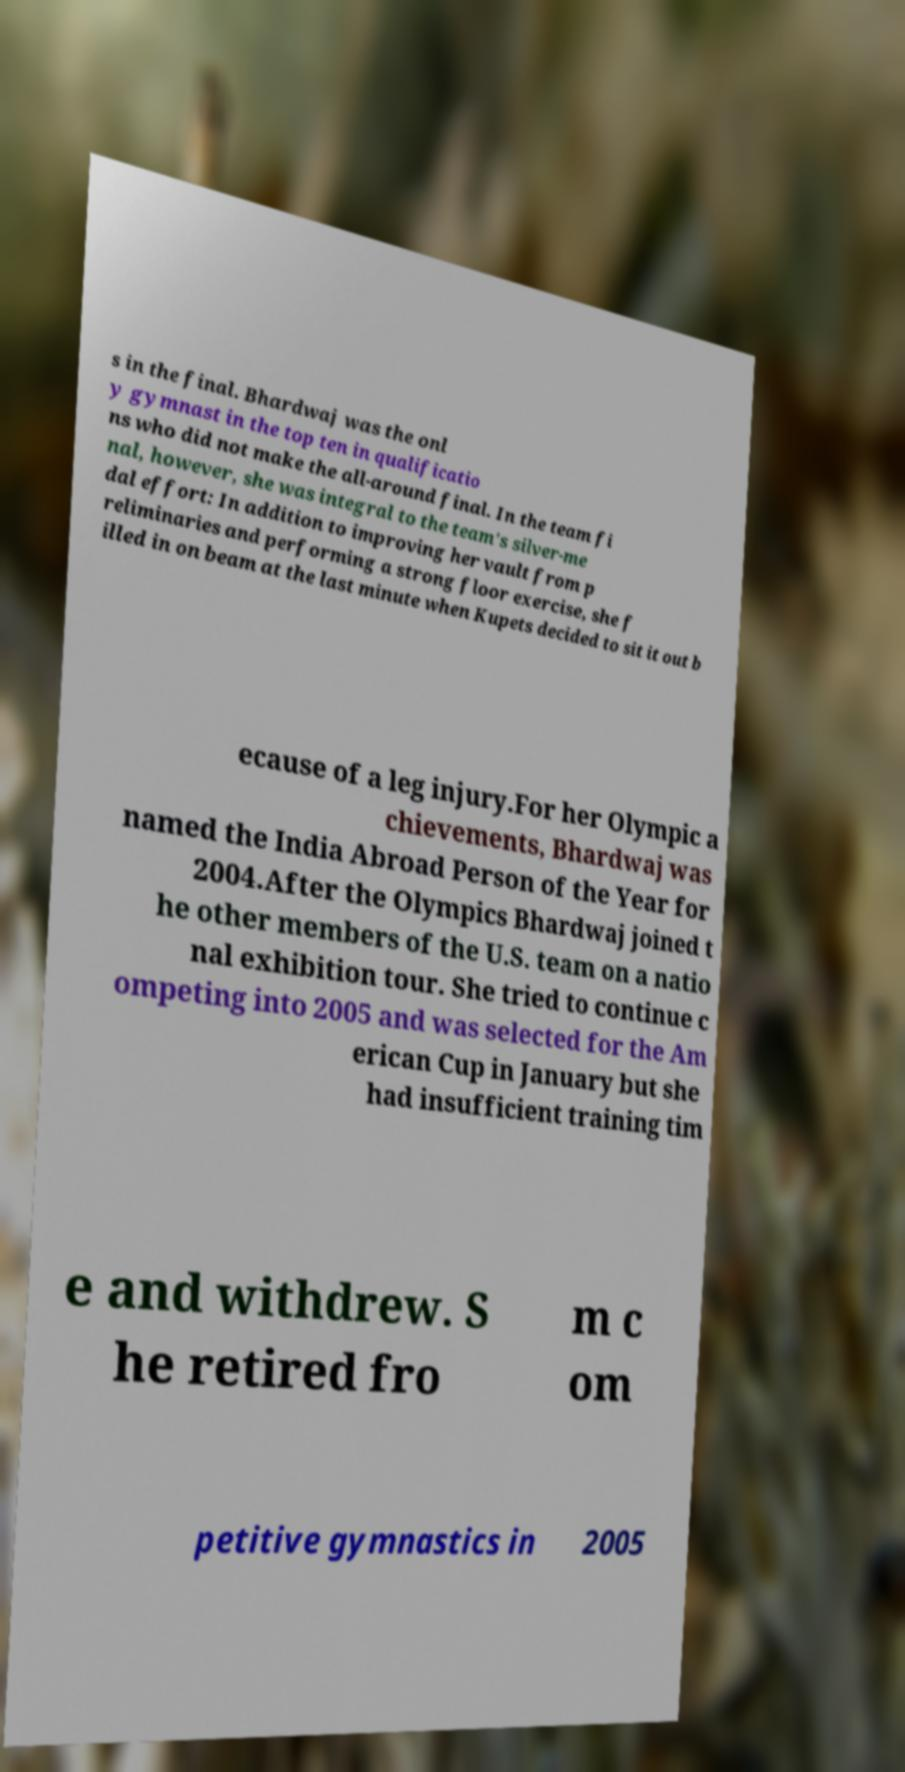There's text embedded in this image that I need extracted. Can you transcribe it verbatim? s in the final. Bhardwaj was the onl y gymnast in the top ten in qualificatio ns who did not make the all-around final. In the team fi nal, however, she was integral to the team's silver-me dal effort: In addition to improving her vault from p reliminaries and performing a strong floor exercise, she f illed in on beam at the last minute when Kupets decided to sit it out b ecause of a leg injury.For her Olympic a chievements, Bhardwaj was named the India Abroad Person of the Year for 2004.After the Olympics Bhardwaj joined t he other members of the U.S. team on a natio nal exhibition tour. She tried to continue c ompeting into 2005 and was selected for the Am erican Cup in January but she had insufficient training tim e and withdrew. S he retired fro m c om petitive gymnastics in 2005 